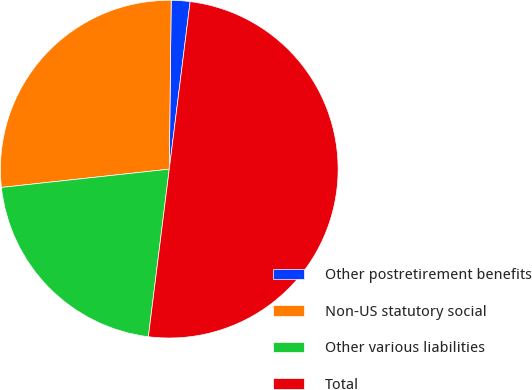Convert chart. <chart><loc_0><loc_0><loc_500><loc_500><pie_chart><fcel>Other postretirement benefits<fcel>Non-US statutory social<fcel>Other various liabilities<fcel>Total<nl><fcel>1.79%<fcel>26.91%<fcel>21.3%<fcel>50.0%<nl></chart> 